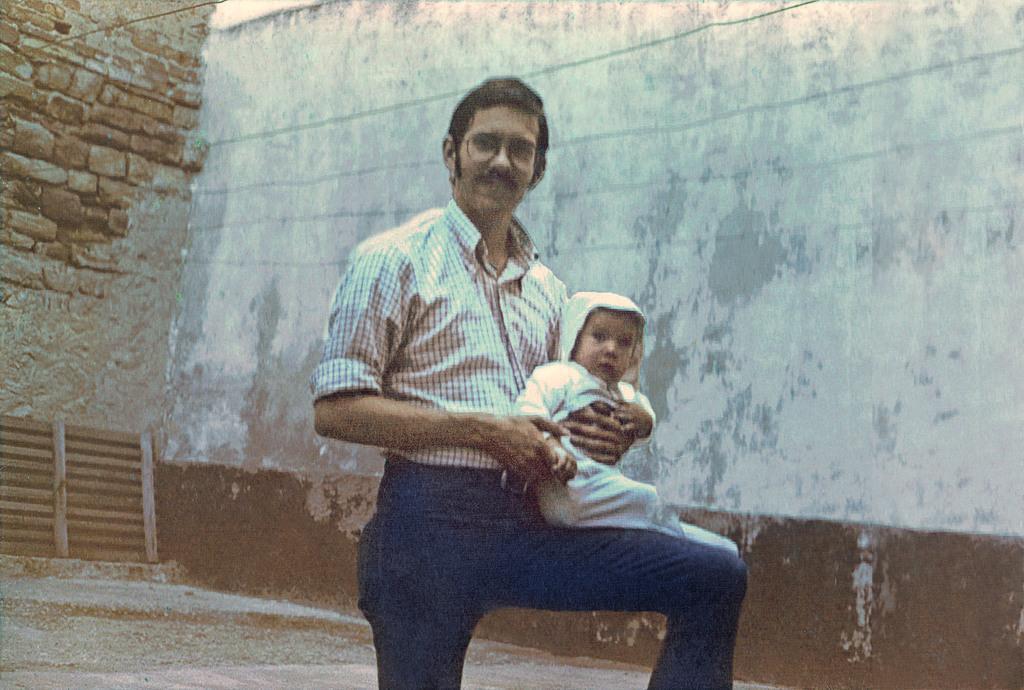Could you give a brief overview of what you see in this image? There is a person smiling, holding a baby and keeping this baby on his lap. In the background, there is white wall on which, there are lines and there is a brick wall. 